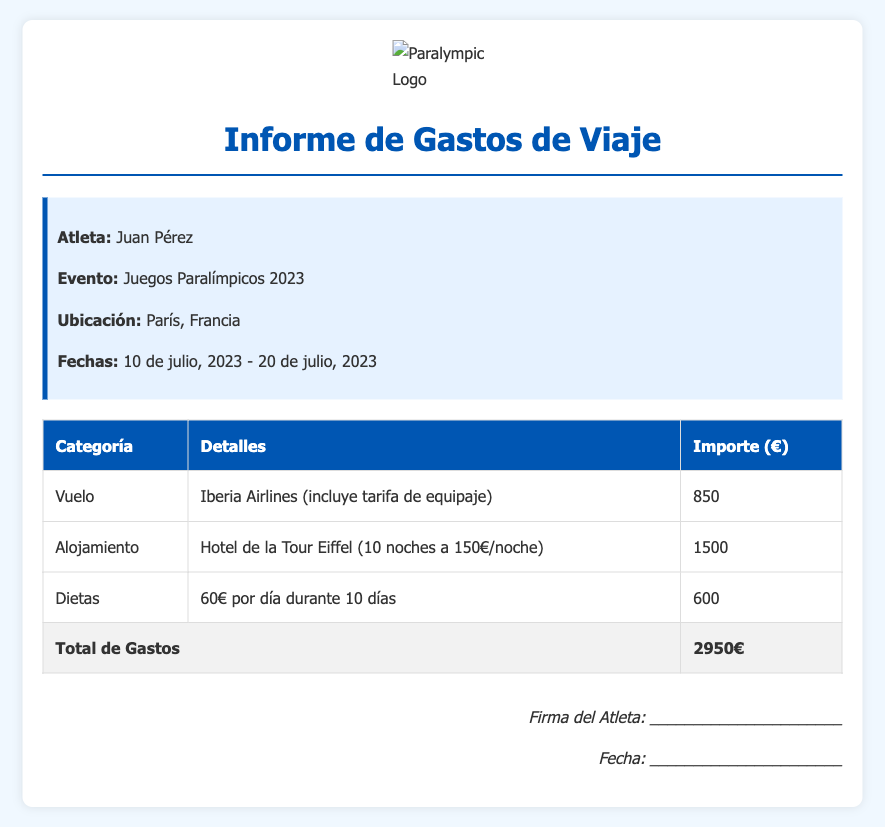¿Cuál es el nombre del atleta? El nombre del atleta se menciona al principio del informe.
Answer: Juan Pérez ¿Cuánto costó el vuelo? El costo del vuelo está especificado en la tabla de gastos.
Answer: 850€ ¿Cuál es la fecha de inicio del evento? La fecha de inicio del evento está listada en la sección de información del atleta.
Answer: 10 de julio, 2023 ¿Cuántos días estuvo alojado el atleta? La cantidad de noches de alojamiento se menciona en la descripción del gasto de alojamiento.
Answer: 10 noches ¿Cuál es el importe total de los gastos? El importe total se encuentra en la fila de totales de la tabla de gastos.
Answer: 2950€ ¿Cuánto se pagó por dietas? La cantidad pagada por dietas está en la tabla en la fila correspondiente a dietas.
Answer: 600€ ¿Qué hotel utilizó el atleta para su alojamiento? El nombre del hotel se menciona en la descripción del gasto de alojamiento en la tabla.
Answer: Hotel de la Tour Eiffel ¿Qué aerolínea se utilizó para el vuelo? La aerolínea se menciona en la descripción del gasto de vuelo en la tabla.
Answer: Iberia Airlines ¿Cuánto es el costo por noche de alojamiento? El costo por noche se menciona en la descripción del gasto de alojamiento.
Answer: 150€/noche 